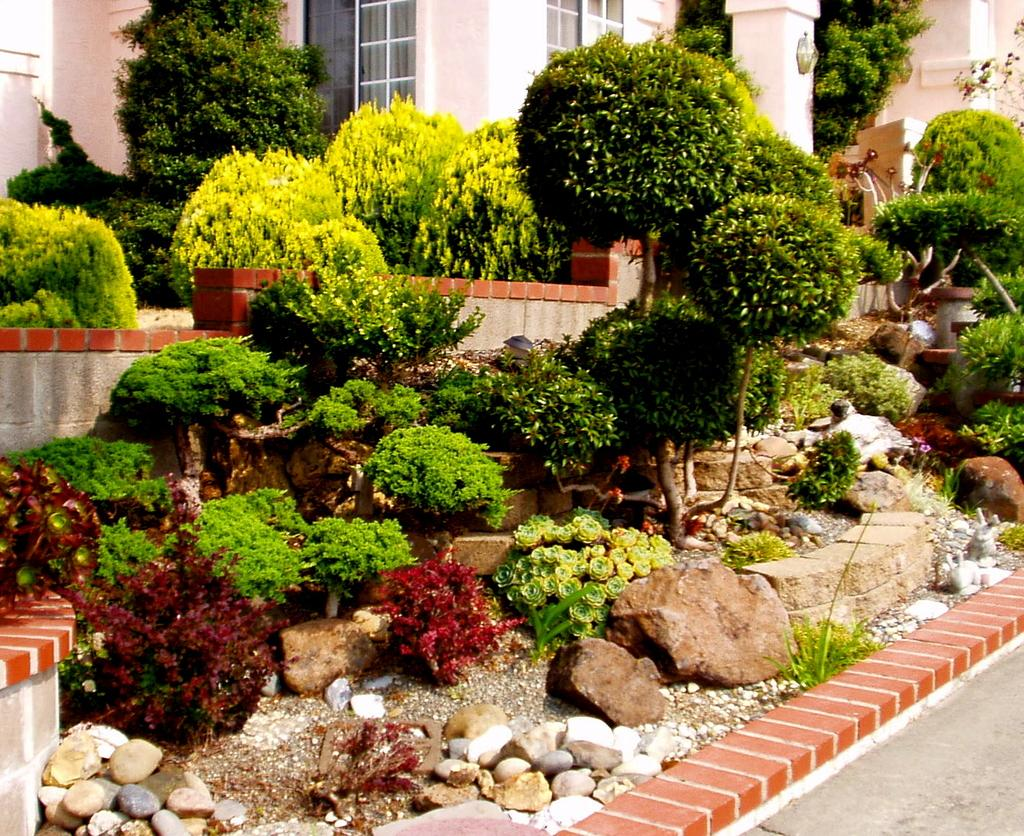What type of living organisms can be seen in the image? Plants can be seen in the image. What type of inanimate objects are present in the image? Stones and a pillar are present in the image. What architectural features can be seen in the image? Windows and a pillar are visible in the image. What type of structure is depicted in the image? There is a building in the image. What type of hospital is shown in the image? There is no hospital present in the image. What degree of education is required to understand the image? The image does not require any specific degree of education to understand it. 